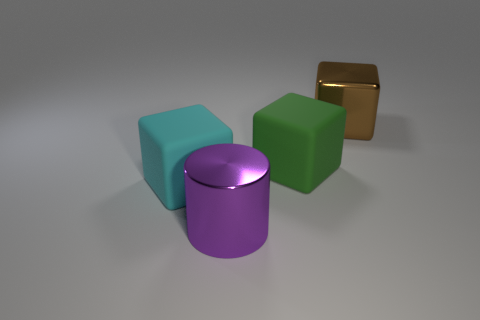Is the number of purple metal cylinders behind the brown shiny object less than the number of cyan cubes?
Your response must be concise. Yes. Does the large brown object have the same shape as the big purple shiny object?
Offer a terse response. No. How big is the shiny object that is in front of the metallic object that is behind the big shiny thing left of the brown shiny object?
Your answer should be compact. Large. There is a large brown thing that is the same shape as the large cyan thing; what is its material?
Offer a terse response. Metal. There is a rubber thing that is behind the large rubber cube on the left side of the purple cylinder; how big is it?
Give a very brief answer. Large. What color is the large metallic cube?
Your answer should be very brief. Brown. How many big cyan things are in front of the big cube right of the green block?
Provide a succinct answer. 1. There is a metal thing in front of the large metal cube; is there a shiny cylinder that is on the right side of it?
Provide a succinct answer. No. There is a big purple cylinder; are there any purple shiny cylinders in front of it?
Provide a short and direct response. No. Do the large rubber object that is to the right of the metal cylinder and the large brown thing have the same shape?
Give a very brief answer. Yes. 